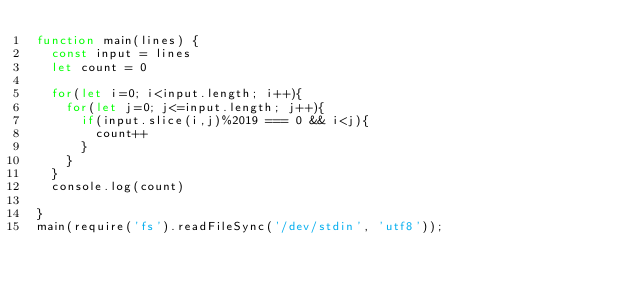Convert code to text. <code><loc_0><loc_0><loc_500><loc_500><_JavaScript_>function main(lines) {
  const input = lines
  let count = 0

  for(let i=0; i<input.length; i++){
    for(let j=0; j<=input.length; j++){
      if(input.slice(i,j)%2019 === 0 && i<j){
        count++
      }
    }
  }
  console.log(count)

}
main(require('fs').readFileSync('/dev/stdin', 'utf8'));
</code> 